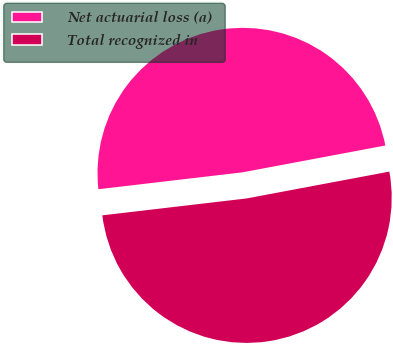Convert chart. <chart><loc_0><loc_0><loc_500><loc_500><pie_chart><fcel>Net actuarial loss (a)<fcel>Total recognized in<nl><fcel>48.9%<fcel>51.1%<nl></chart> 